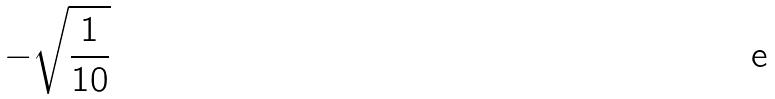<formula> <loc_0><loc_0><loc_500><loc_500>- \sqrt { \frac { 1 } { 1 0 } }</formula> 